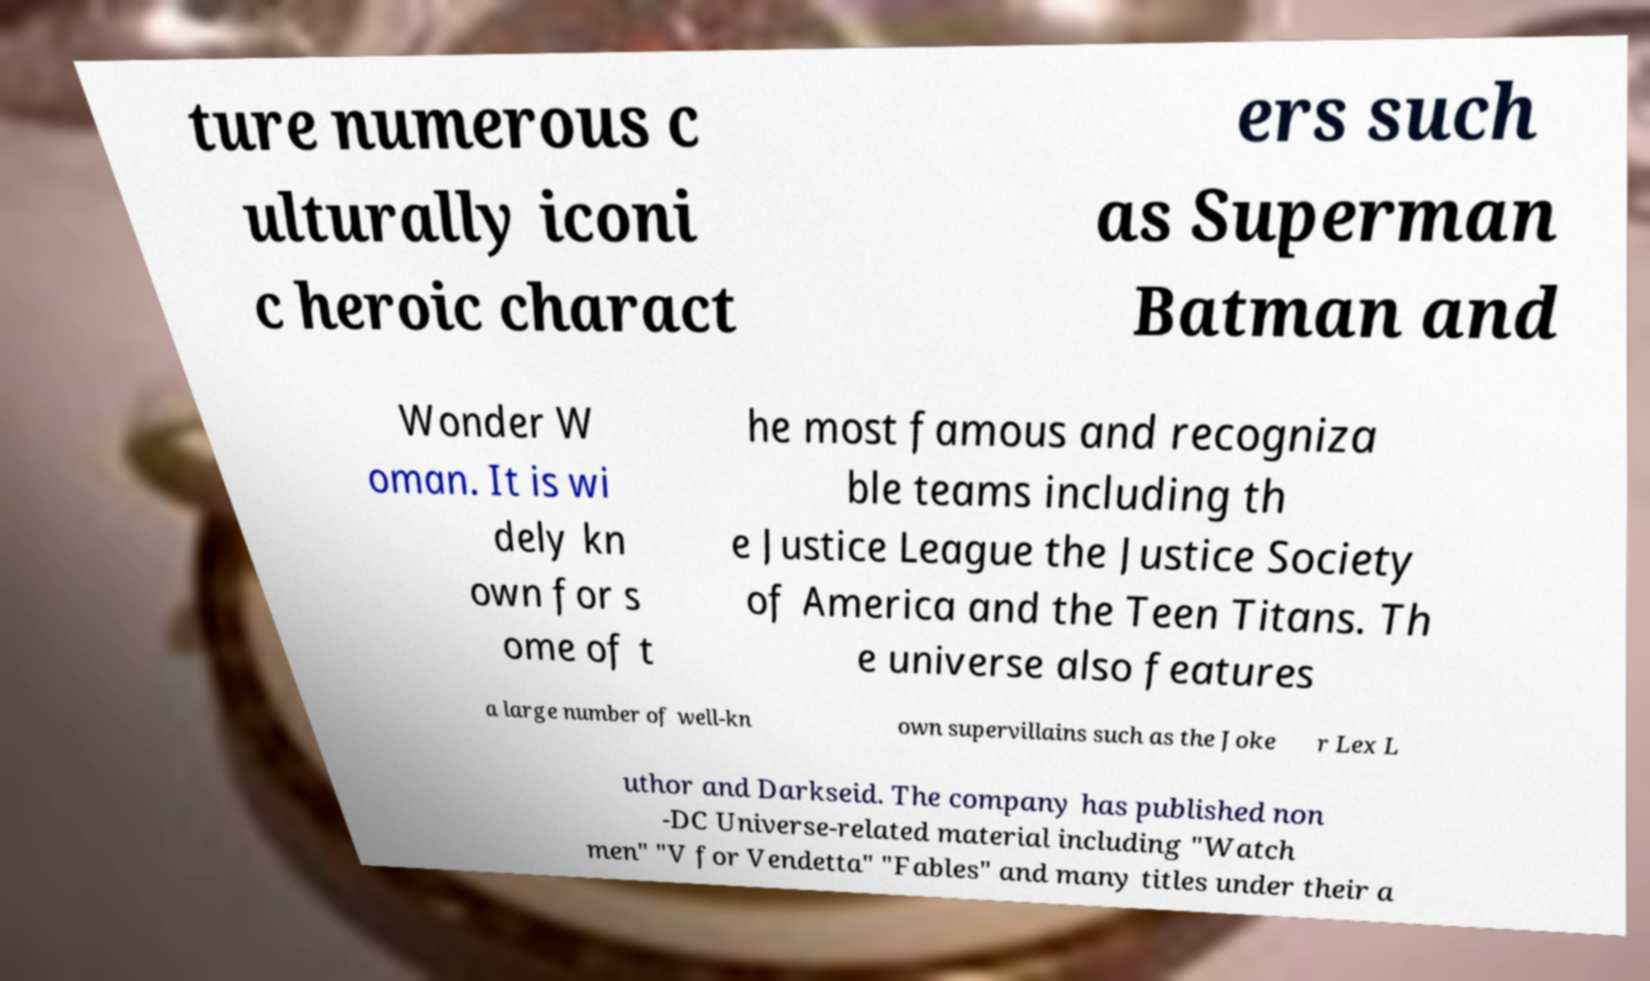Can you accurately transcribe the text from the provided image for me? ture numerous c ulturally iconi c heroic charact ers such as Superman Batman and Wonder W oman. It is wi dely kn own for s ome of t he most famous and recogniza ble teams including th e Justice League the Justice Society of America and the Teen Titans. Th e universe also features a large number of well-kn own supervillains such as the Joke r Lex L uthor and Darkseid. The company has published non -DC Universe-related material including "Watch men" "V for Vendetta" "Fables" and many titles under their a 